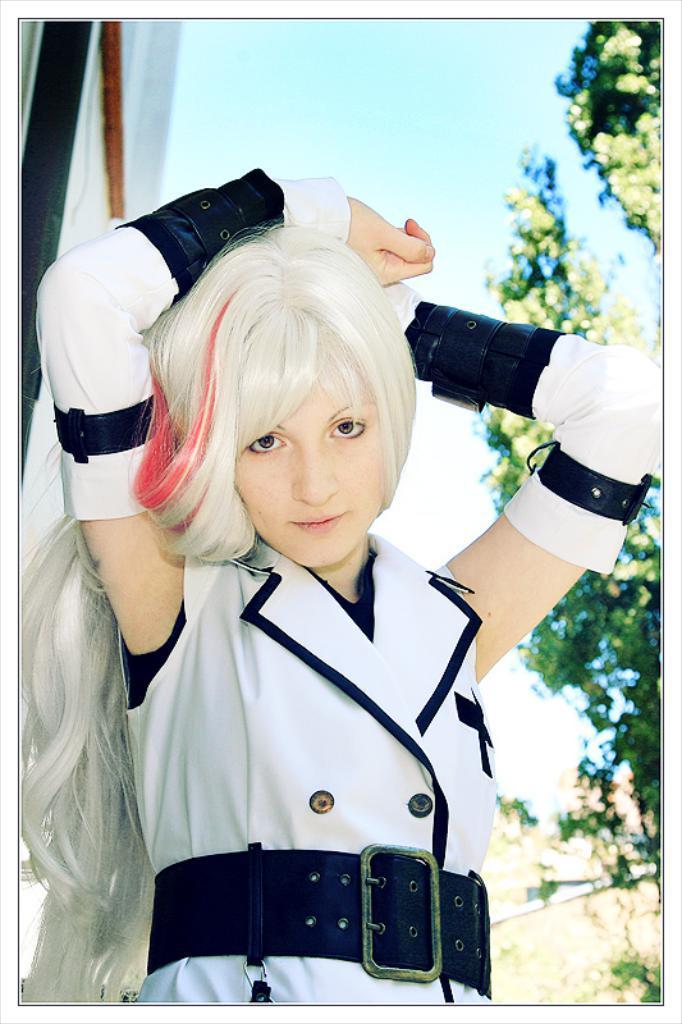How would you summarize this image in a sentence or two? In this image, we can see a woman in white dress wearing a belt and watching. Background we can see the sky, pole, cloth and trees. 